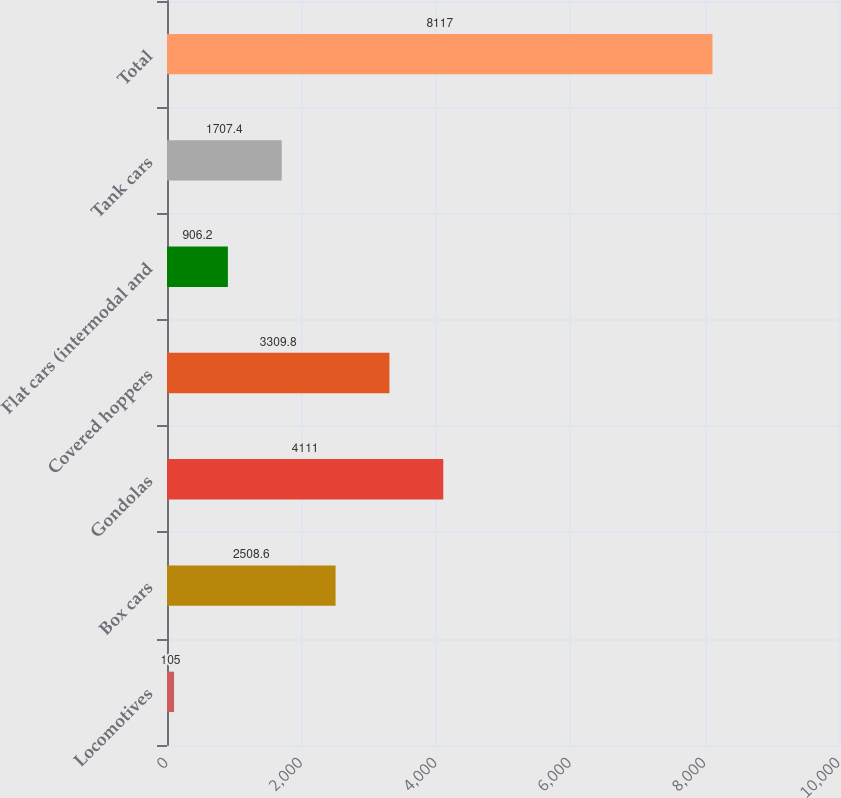Convert chart to OTSL. <chart><loc_0><loc_0><loc_500><loc_500><bar_chart><fcel>Locomotives<fcel>Box cars<fcel>Gondolas<fcel>Covered hoppers<fcel>Flat cars (intermodal and<fcel>Tank cars<fcel>Total<nl><fcel>105<fcel>2508.6<fcel>4111<fcel>3309.8<fcel>906.2<fcel>1707.4<fcel>8117<nl></chart> 